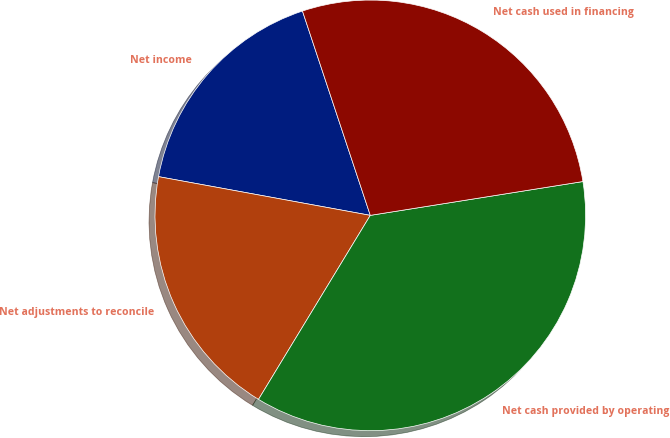Convert chart to OTSL. <chart><loc_0><loc_0><loc_500><loc_500><pie_chart><fcel>Net income<fcel>Net adjustments to reconcile<fcel>Net cash provided by operating<fcel>Net cash used in financing<nl><fcel>17.02%<fcel>19.19%<fcel>36.2%<fcel>27.59%<nl></chart> 